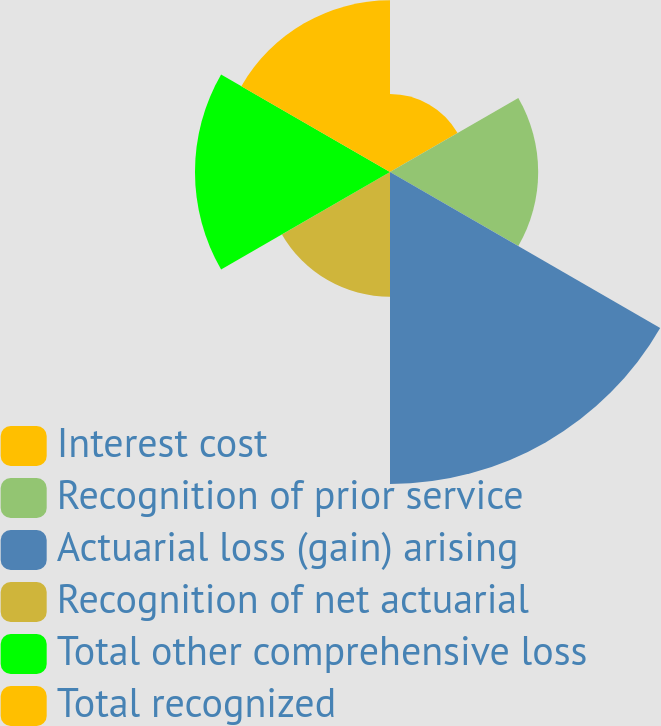Convert chart to OTSL. <chart><loc_0><loc_0><loc_500><loc_500><pie_chart><fcel>Interest cost<fcel>Recognition of prior service<fcel>Actuarial loss (gain) arising<fcel>Recognition of net actuarial<fcel>Total other comprehensive loss<fcel>Total recognized<nl><fcel>7.58%<fcel>14.39%<fcel>30.3%<fcel>12.12%<fcel>18.94%<fcel>16.67%<nl></chart> 